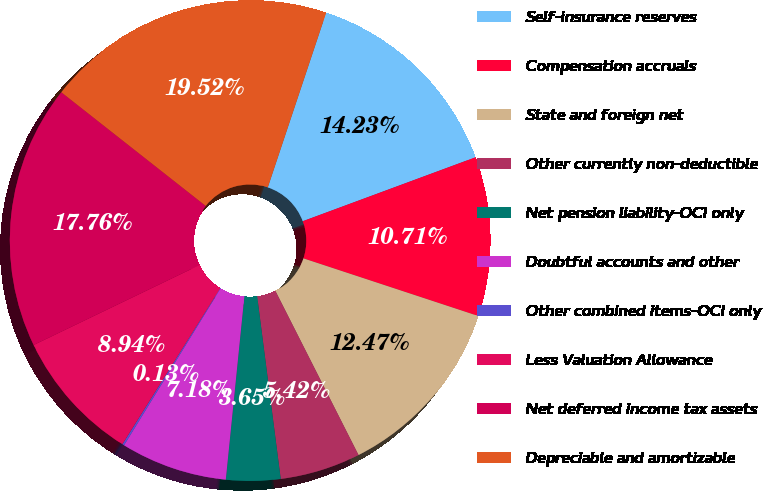Convert chart to OTSL. <chart><loc_0><loc_0><loc_500><loc_500><pie_chart><fcel>Self-insurance reserves<fcel>Compensation accruals<fcel>State and foreign net<fcel>Other currently non-deductible<fcel>Net pension liability-OCI only<fcel>Doubtful accounts and other<fcel>Other combined items-OCI only<fcel>Less Valuation Allowance<fcel>Net deferred income tax assets<fcel>Depreciable and amortizable<nl><fcel>14.23%<fcel>10.71%<fcel>12.47%<fcel>5.42%<fcel>3.65%<fcel>7.18%<fcel>0.13%<fcel>8.94%<fcel>17.76%<fcel>19.52%<nl></chart> 